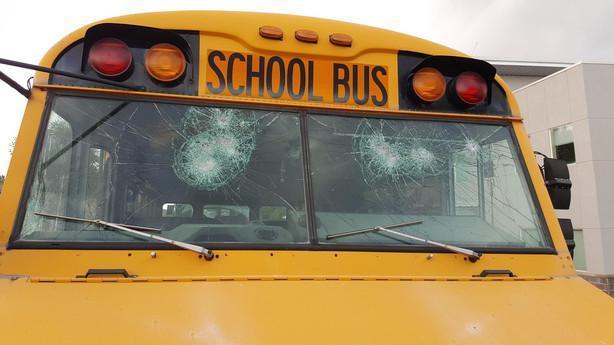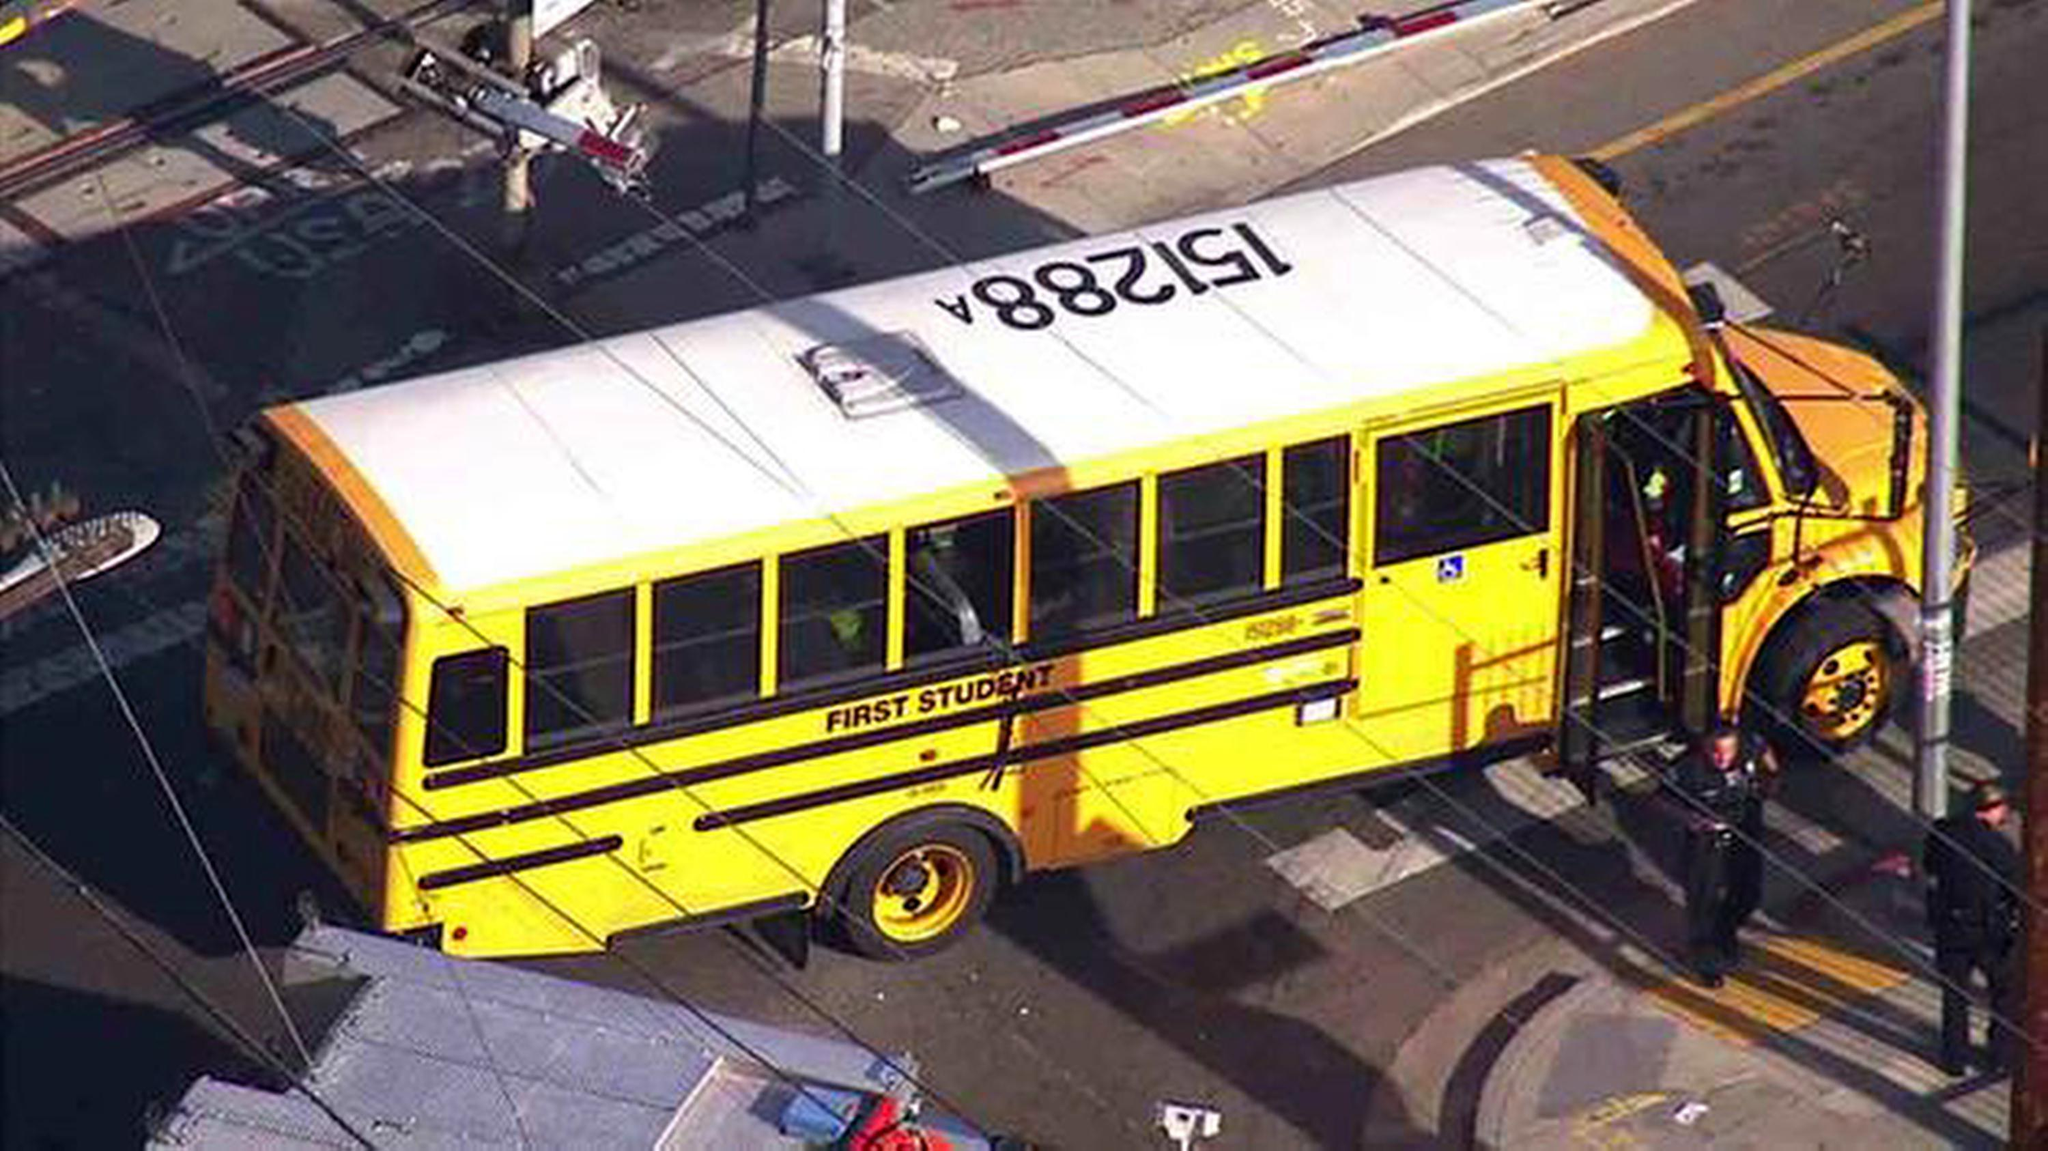The first image is the image on the left, the second image is the image on the right. Assess this claim about the two images: "A school bus seen from above has a white roof with identifying number, and a handicap access door directly behind a passenger door with steps.". Correct or not? Answer yes or no. Yes. The first image is the image on the left, the second image is the image on the right. Assess this claim about the two images: "A number is printed on the top of the bus in one of the images.". Correct or not? Answer yes or no. Yes. 